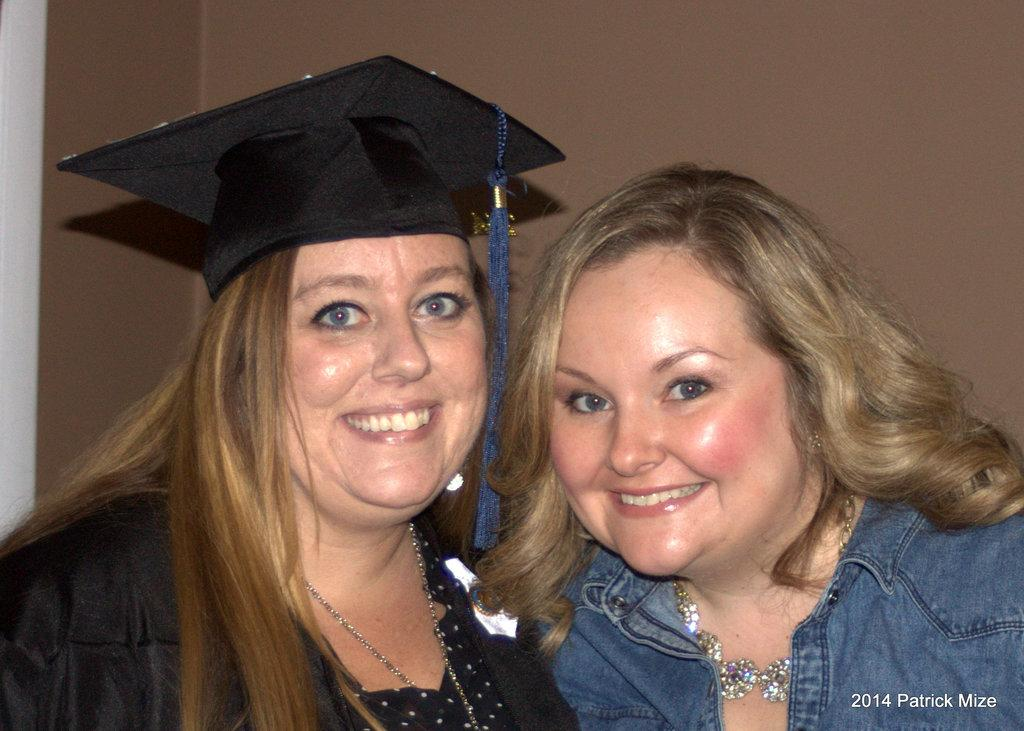How many people are in the image? There are two women in the image. What is the facial expression of the women in the image? Both women are smiling in the image. What are the women doing in the image? The women are posing for a picture. Can you describe the clothing of the woman on the left side? The woman on the left side is wearing a cap on her head. What can be seen in the background of the image? There is a wall in the background of the image. What is the cause of the taste in the image? There is no taste or cause mentioned in the image; it features two women posing for a picture. 